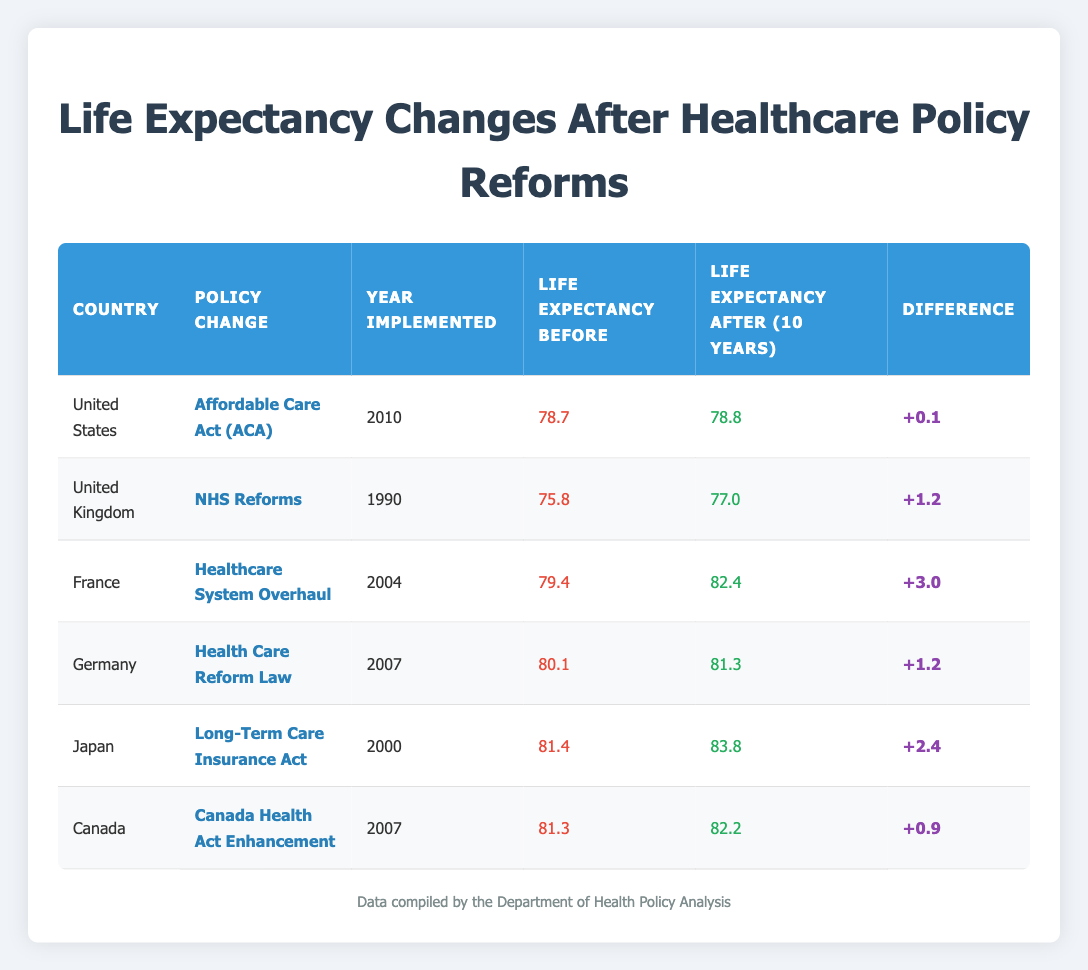What was the life expectancy in France after the healthcare system overhaul? According to the table, the life expectancy in France after the healthcare system overhaul in 2014 was 82.4.
Answer: 82.4 Which country had the largest increase in life expectancy after its healthcare policy change? By examining the differences in life expectancy before and after, France had the largest increase of 3.0 years (from 79.4 to 82.4).
Answer: France What was the life expectancy in Japan before the implementation of the Long-Term Care Insurance Act? The table shows that Japan's life expectancy before the policy was 81.4 in the year 2000.
Answer: 81.4 Did the United States see a decrease in life expectancy after the Affordable Care Act? The table indicates that the life expectancy did not decrease; it increased slightly from 78.7 to 78.8.
Answer: No What is the average life expectancy before the healthcare policy changes in the countries listed? The life expectancies before the changes are 78.7 (US), 75.8 (UK), 79.4 (France), 80.1 (Germany), 81.4 (Japan), and 81.3 (Canada). Adding these yields 477.6. There are 6 countries, so the average is 477.6 / 6 = 79.6.
Answer: 79.6 What was the difference in life expectancy for Canada after the Canada Health Act Enhancement? From the data, Canada had a life expectancy before of 81.3 and after of 82.2, so the difference is 82.2 - 81.3 = 0.9.
Answer: 0.9 Which two countries experienced the same increase in life expectancy of 1.2 years due to their healthcare reforms? The table shows that both the United Kingdom and Germany experienced an increase of 1.2 years. For the UK, life expectancy went from 75.8 to 77.0, and for Germany, it went from 80.1 to 81.3.
Answer: United Kingdom and Germany What was the year implemented for the healthcare system overhaul in France? The data specifies that the healthcare system overhaul in France was implemented in the year 2004.
Answer: 2004 Which country had the highest life expectancy after the healthcare policy change and what was the value? From the table, Japan had the highest life expectancy after its policy change at 83.8 in 2010.
Answer: Japan, 83.8 